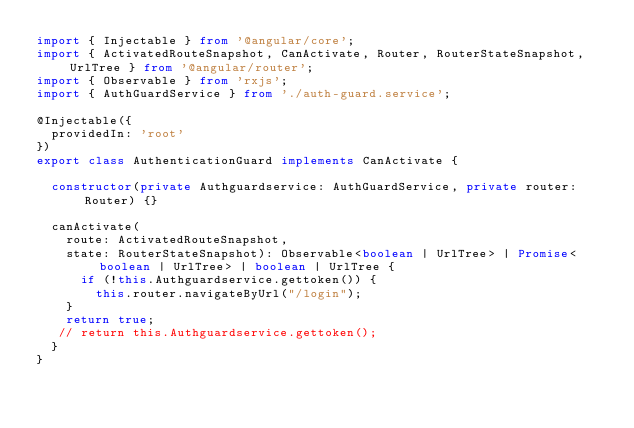<code> <loc_0><loc_0><loc_500><loc_500><_TypeScript_>import { Injectable } from '@angular/core';
import { ActivatedRouteSnapshot, CanActivate, Router, RouterStateSnapshot, UrlTree } from '@angular/router';
import { Observable } from 'rxjs';
import { AuthGuardService } from './auth-guard.service';

@Injectable({
  providedIn: 'root'
})
export class AuthenticationGuard implements CanActivate {

  constructor(private Authguardservice: AuthGuardService, private router: Router) {}  

  canActivate(
    route: ActivatedRouteSnapshot,
    state: RouterStateSnapshot): Observable<boolean | UrlTree> | Promise<boolean | UrlTree> | boolean | UrlTree {
      if (!this.Authguardservice.gettoken()) {  
        this.router.navigateByUrl("/login");  
    }  
    return true;
   // return this.Authguardservice.gettoken();  
  }
}
</code> 